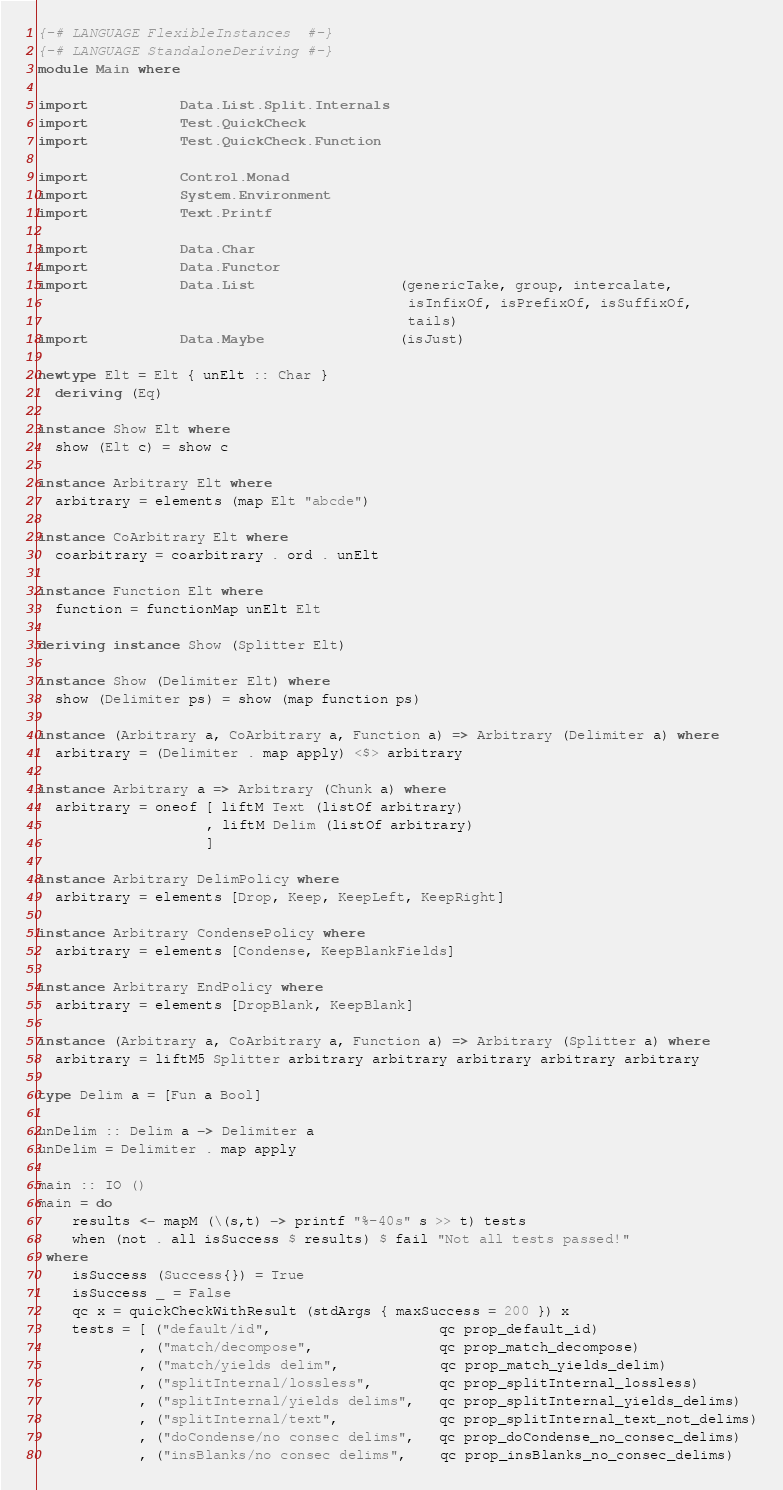<code> <loc_0><loc_0><loc_500><loc_500><_Haskell_>{-# LANGUAGE FlexibleInstances  #-}
{-# LANGUAGE StandaloneDeriving #-}
module Main where

import           Data.List.Split.Internals
import           Test.QuickCheck
import           Test.QuickCheck.Function

import           Control.Monad
import           System.Environment
import           Text.Printf

import           Data.Char
import           Data.Functor
import           Data.List                 (genericTake, group, intercalate,
                                            isInfixOf, isPrefixOf, isSuffixOf,
                                            tails)
import           Data.Maybe                (isJust)

newtype Elt = Elt { unElt :: Char }
  deriving (Eq)

instance Show Elt where
  show (Elt c) = show c

instance Arbitrary Elt where
  arbitrary = elements (map Elt "abcde")

instance CoArbitrary Elt where
  coarbitrary = coarbitrary . ord . unElt

instance Function Elt where
  function = functionMap unElt Elt

deriving instance Show (Splitter Elt)

instance Show (Delimiter Elt) where
  show (Delimiter ps) = show (map function ps)

instance (Arbitrary a, CoArbitrary a, Function a) => Arbitrary (Delimiter a) where
  arbitrary = (Delimiter . map apply) <$> arbitrary

instance Arbitrary a => Arbitrary (Chunk a) where
  arbitrary = oneof [ liftM Text (listOf arbitrary)
                    , liftM Delim (listOf arbitrary)
                    ]

instance Arbitrary DelimPolicy where
  arbitrary = elements [Drop, Keep, KeepLeft, KeepRight]

instance Arbitrary CondensePolicy where
  arbitrary = elements [Condense, KeepBlankFields]

instance Arbitrary EndPolicy where
  arbitrary = elements [DropBlank, KeepBlank]

instance (Arbitrary a, CoArbitrary a, Function a) => Arbitrary (Splitter a) where
  arbitrary = liftM5 Splitter arbitrary arbitrary arbitrary arbitrary arbitrary

type Delim a = [Fun a Bool]

unDelim :: Delim a -> Delimiter a
unDelim = Delimiter . map apply

main :: IO ()
main = do
    results <- mapM (\(s,t) -> printf "%-40s" s >> t) tests
    when (not . all isSuccess $ results) $ fail "Not all tests passed!"
 where
    isSuccess (Success{}) = True
    isSuccess _ = False
    qc x = quickCheckWithResult (stdArgs { maxSuccess = 200 }) x
    tests = [ ("default/id",                    qc prop_default_id)
            , ("match/decompose",               qc prop_match_decompose)
            , ("match/yields delim",            qc prop_match_yields_delim)
            , ("splitInternal/lossless",        qc prop_splitInternal_lossless)
            , ("splitInternal/yields delims",   qc prop_splitInternal_yields_delims)
            , ("splitInternal/text",            qc prop_splitInternal_text_not_delims)
            , ("doCondense/no consec delims",   qc prop_doCondense_no_consec_delims)
            , ("insBlanks/no consec delims",    qc prop_insBlanks_no_consec_delims)</code> 